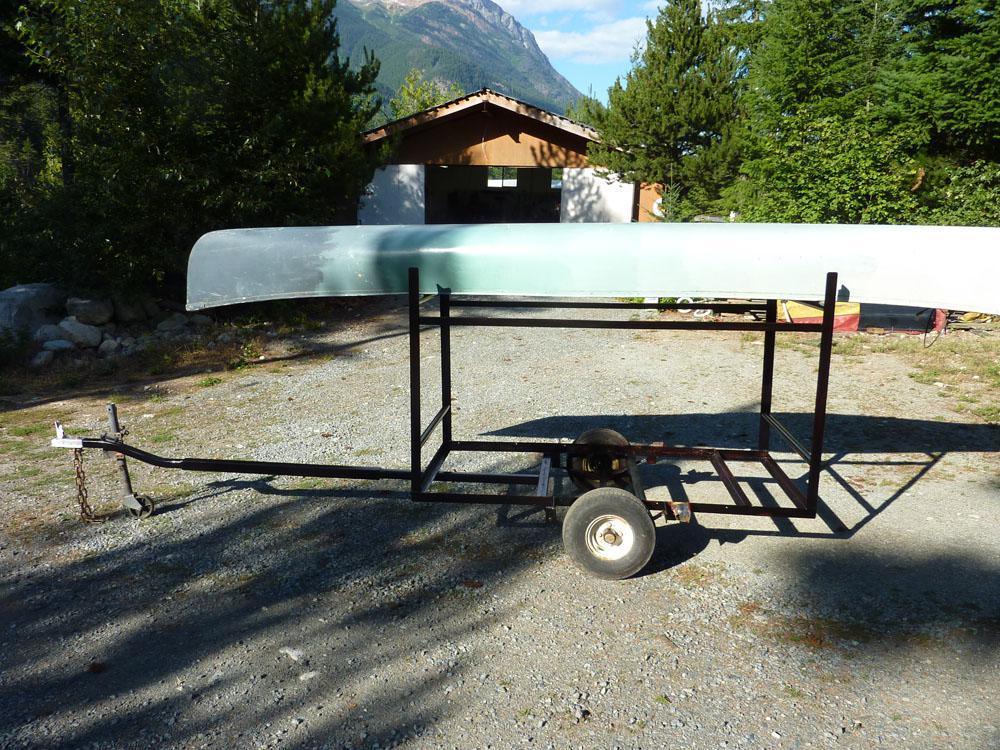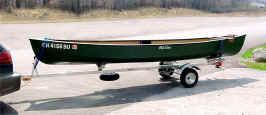The first image is the image on the left, the second image is the image on the right. Given the left and right images, does the statement "There are at least four canoes loaded up to be transported elsewhere." hold true? Answer yes or no. No. 